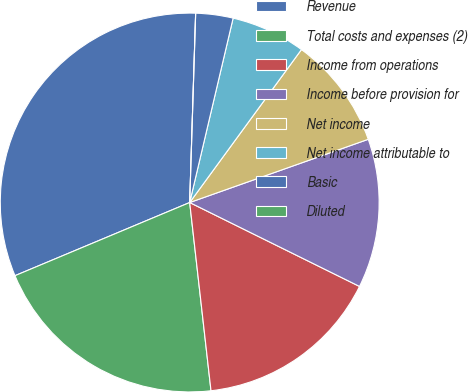Convert chart. <chart><loc_0><loc_0><loc_500><loc_500><pie_chart><fcel>Revenue<fcel>Total costs and expenses (2)<fcel>Income from operations<fcel>Income before provision for<fcel>Net income<fcel>Net income attributable to<fcel>Basic<fcel>Diluted<nl><fcel>31.81%<fcel>20.48%<fcel>15.9%<fcel>12.72%<fcel>9.54%<fcel>6.36%<fcel>3.18%<fcel>0.0%<nl></chart> 